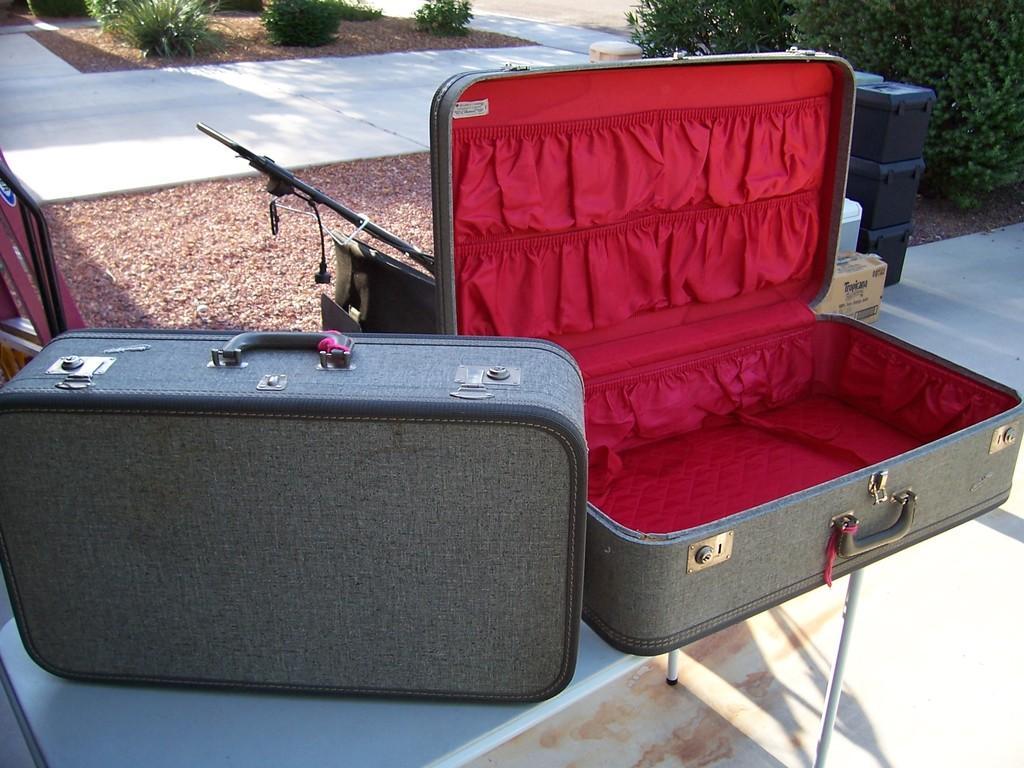Can you describe this image briefly? In this picture there are two suitcases kept on the table, they have handles to carry, there are also three boxes kept on the left side and there are some plants here is a walkway 